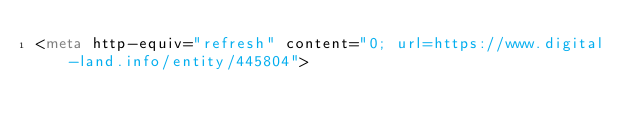<code> <loc_0><loc_0><loc_500><loc_500><_HTML_><meta http-equiv="refresh" content="0; url=https://www.digital-land.info/entity/445804"></code> 